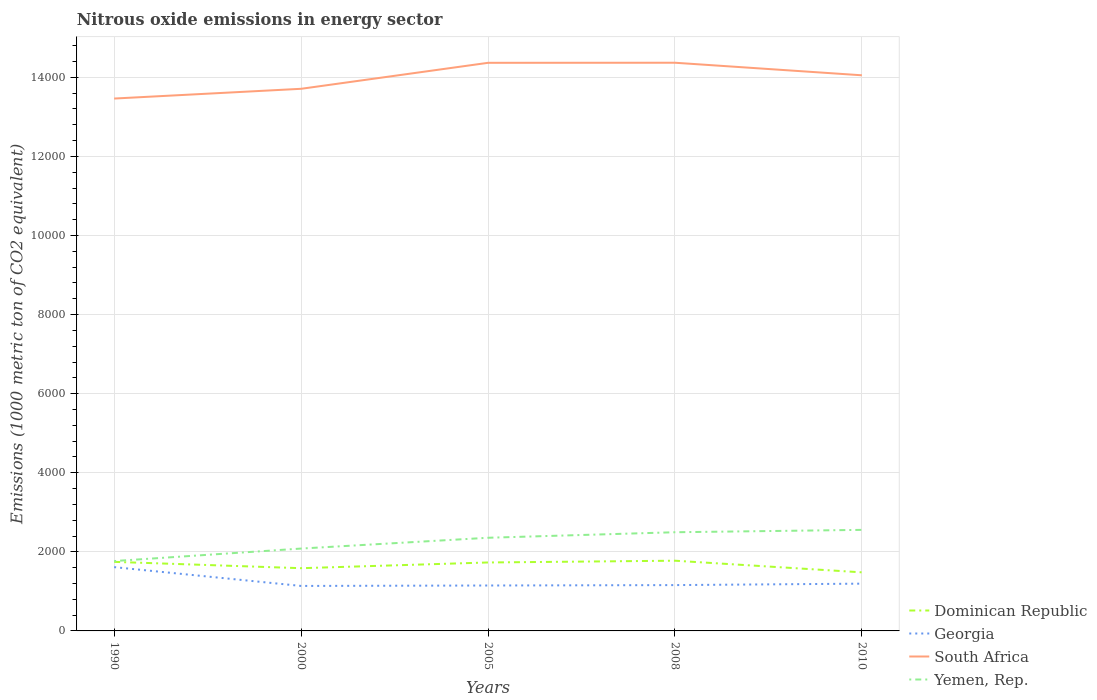Is the number of lines equal to the number of legend labels?
Make the answer very short. Yes. Across all years, what is the maximum amount of nitrous oxide emitted in Georgia?
Offer a very short reply. 1137.6. What is the total amount of nitrous oxide emitted in Dominican Republic in the graph?
Your answer should be compact. 294.2. What is the difference between the highest and the second highest amount of nitrous oxide emitted in South Africa?
Ensure brevity in your answer.  905.7. What is the difference between the highest and the lowest amount of nitrous oxide emitted in Dominican Republic?
Provide a short and direct response. 3. Is the amount of nitrous oxide emitted in South Africa strictly greater than the amount of nitrous oxide emitted in Yemen, Rep. over the years?
Provide a succinct answer. No. How many years are there in the graph?
Your answer should be very brief. 5. Does the graph contain grids?
Your response must be concise. Yes. How are the legend labels stacked?
Make the answer very short. Vertical. What is the title of the graph?
Provide a short and direct response. Nitrous oxide emissions in energy sector. Does "Portugal" appear as one of the legend labels in the graph?
Your response must be concise. No. What is the label or title of the Y-axis?
Provide a short and direct response. Emissions (1000 metric ton of CO2 equivalent). What is the Emissions (1000 metric ton of CO2 equivalent) of Dominican Republic in 1990?
Make the answer very short. 1746.5. What is the Emissions (1000 metric ton of CO2 equivalent) in Georgia in 1990?
Keep it short and to the point. 1613.4. What is the Emissions (1000 metric ton of CO2 equivalent) in South Africa in 1990?
Make the answer very short. 1.35e+04. What is the Emissions (1000 metric ton of CO2 equivalent) of Yemen, Rep. in 1990?
Make the answer very short. 1766.7. What is the Emissions (1000 metric ton of CO2 equivalent) of Dominican Republic in 2000?
Your answer should be very brief. 1586.4. What is the Emissions (1000 metric ton of CO2 equivalent) of Georgia in 2000?
Your response must be concise. 1137.6. What is the Emissions (1000 metric ton of CO2 equivalent) in South Africa in 2000?
Provide a succinct answer. 1.37e+04. What is the Emissions (1000 metric ton of CO2 equivalent) of Yemen, Rep. in 2000?
Provide a succinct answer. 2082.9. What is the Emissions (1000 metric ton of CO2 equivalent) in Dominican Republic in 2005?
Your response must be concise. 1731. What is the Emissions (1000 metric ton of CO2 equivalent) of Georgia in 2005?
Offer a terse response. 1148.6. What is the Emissions (1000 metric ton of CO2 equivalent) in South Africa in 2005?
Give a very brief answer. 1.44e+04. What is the Emissions (1000 metric ton of CO2 equivalent) in Yemen, Rep. in 2005?
Your answer should be very brief. 2356. What is the Emissions (1000 metric ton of CO2 equivalent) in Dominican Republic in 2008?
Your answer should be compact. 1775.7. What is the Emissions (1000 metric ton of CO2 equivalent) in Georgia in 2008?
Provide a short and direct response. 1158.8. What is the Emissions (1000 metric ton of CO2 equivalent) in South Africa in 2008?
Provide a short and direct response. 1.44e+04. What is the Emissions (1000 metric ton of CO2 equivalent) in Yemen, Rep. in 2008?
Your answer should be compact. 2495.7. What is the Emissions (1000 metric ton of CO2 equivalent) of Dominican Republic in 2010?
Your answer should be compact. 1481.5. What is the Emissions (1000 metric ton of CO2 equivalent) in Georgia in 2010?
Offer a terse response. 1195.6. What is the Emissions (1000 metric ton of CO2 equivalent) in South Africa in 2010?
Give a very brief answer. 1.41e+04. What is the Emissions (1000 metric ton of CO2 equivalent) of Yemen, Rep. in 2010?
Your answer should be very brief. 2555.7. Across all years, what is the maximum Emissions (1000 metric ton of CO2 equivalent) of Dominican Republic?
Your answer should be very brief. 1775.7. Across all years, what is the maximum Emissions (1000 metric ton of CO2 equivalent) of Georgia?
Provide a succinct answer. 1613.4. Across all years, what is the maximum Emissions (1000 metric ton of CO2 equivalent) of South Africa?
Provide a succinct answer. 1.44e+04. Across all years, what is the maximum Emissions (1000 metric ton of CO2 equivalent) in Yemen, Rep.?
Provide a succinct answer. 2555.7. Across all years, what is the minimum Emissions (1000 metric ton of CO2 equivalent) in Dominican Republic?
Give a very brief answer. 1481.5. Across all years, what is the minimum Emissions (1000 metric ton of CO2 equivalent) of Georgia?
Provide a succinct answer. 1137.6. Across all years, what is the minimum Emissions (1000 metric ton of CO2 equivalent) of South Africa?
Give a very brief answer. 1.35e+04. Across all years, what is the minimum Emissions (1000 metric ton of CO2 equivalent) in Yemen, Rep.?
Your answer should be compact. 1766.7. What is the total Emissions (1000 metric ton of CO2 equivalent) of Dominican Republic in the graph?
Give a very brief answer. 8321.1. What is the total Emissions (1000 metric ton of CO2 equivalent) in Georgia in the graph?
Your answer should be very brief. 6254. What is the total Emissions (1000 metric ton of CO2 equivalent) of South Africa in the graph?
Offer a terse response. 7.00e+04. What is the total Emissions (1000 metric ton of CO2 equivalent) of Yemen, Rep. in the graph?
Ensure brevity in your answer.  1.13e+04. What is the difference between the Emissions (1000 metric ton of CO2 equivalent) of Dominican Republic in 1990 and that in 2000?
Your answer should be compact. 160.1. What is the difference between the Emissions (1000 metric ton of CO2 equivalent) in Georgia in 1990 and that in 2000?
Provide a short and direct response. 475.8. What is the difference between the Emissions (1000 metric ton of CO2 equivalent) in South Africa in 1990 and that in 2000?
Offer a very short reply. -246.5. What is the difference between the Emissions (1000 metric ton of CO2 equivalent) of Yemen, Rep. in 1990 and that in 2000?
Provide a succinct answer. -316.2. What is the difference between the Emissions (1000 metric ton of CO2 equivalent) in Dominican Republic in 1990 and that in 2005?
Keep it short and to the point. 15.5. What is the difference between the Emissions (1000 metric ton of CO2 equivalent) of Georgia in 1990 and that in 2005?
Make the answer very short. 464.8. What is the difference between the Emissions (1000 metric ton of CO2 equivalent) of South Africa in 1990 and that in 2005?
Make the answer very short. -903.7. What is the difference between the Emissions (1000 metric ton of CO2 equivalent) in Yemen, Rep. in 1990 and that in 2005?
Your response must be concise. -589.3. What is the difference between the Emissions (1000 metric ton of CO2 equivalent) of Dominican Republic in 1990 and that in 2008?
Ensure brevity in your answer.  -29.2. What is the difference between the Emissions (1000 metric ton of CO2 equivalent) of Georgia in 1990 and that in 2008?
Offer a terse response. 454.6. What is the difference between the Emissions (1000 metric ton of CO2 equivalent) of South Africa in 1990 and that in 2008?
Ensure brevity in your answer.  -905.7. What is the difference between the Emissions (1000 metric ton of CO2 equivalent) of Yemen, Rep. in 1990 and that in 2008?
Your answer should be very brief. -729. What is the difference between the Emissions (1000 metric ton of CO2 equivalent) in Dominican Republic in 1990 and that in 2010?
Make the answer very short. 265. What is the difference between the Emissions (1000 metric ton of CO2 equivalent) of Georgia in 1990 and that in 2010?
Ensure brevity in your answer.  417.8. What is the difference between the Emissions (1000 metric ton of CO2 equivalent) in South Africa in 1990 and that in 2010?
Offer a very short reply. -588.2. What is the difference between the Emissions (1000 metric ton of CO2 equivalent) of Yemen, Rep. in 1990 and that in 2010?
Offer a very short reply. -789. What is the difference between the Emissions (1000 metric ton of CO2 equivalent) in Dominican Republic in 2000 and that in 2005?
Provide a short and direct response. -144.6. What is the difference between the Emissions (1000 metric ton of CO2 equivalent) of Georgia in 2000 and that in 2005?
Offer a terse response. -11. What is the difference between the Emissions (1000 metric ton of CO2 equivalent) of South Africa in 2000 and that in 2005?
Your response must be concise. -657.2. What is the difference between the Emissions (1000 metric ton of CO2 equivalent) in Yemen, Rep. in 2000 and that in 2005?
Provide a succinct answer. -273.1. What is the difference between the Emissions (1000 metric ton of CO2 equivalent) in Dominican Republic in 2000 and that in 2008?
Offer a terse response. -189.3. What is the difference between the Emissions (1000 metric ton of CO2 equivalent) in Georgia in 2000 and that in 2008?
Offer a very short reply. -21.2. What is the difference between the Emissions (1000 metric ton of CO2 equivalent) of South Africa in 2000 and that in 2008?
Ensure brevity in your answer.  -659.2. What is the difference between the Emissions (1000 metric ton of CO2 equivalent) in Yemen, Rep. in 2000 and that in 2008?
Ensure brevity in your answer.  -412.8. What is the difference between the Emissions (1000 metric ton of CO2 equivalent) in Dominican Republic in 2000 and that in 2010?
Provide a short and direct response. 104.9. What is the difference between the Emissions (1000 metric ton of CO2 equivalent) in Georgia in 2000 and that in 2010?
Your response must be concise. -58. What is the difference between the Emissions (1000 metric ton of CO2 equivalent) of South Africa in 2000 and that in 2010?
Your response must be concise. -341.7. What is the difference between the Emissions (1000 metric ton of CO2 equivalent) in Yemen, Rep. in 2000 and that in 2010?
Make the answer very short. -472.8. What is the difference between the Emissions (1000 metric ton of CO2 equivalent) in Dominican Republic in 2005 and that in 2008?
Make the answer very short. -44.7. What is the difference between the Emissions (1000 metric ton of CO2 equivalent) in South Africa in 2005 and that in 2008?
Provide a short and direct response. -2. What is the difference between the Emissions (1000 metric ton of CO2 equivalent) in Yemen, Rep. in 2005 and that in 2008?
Your answer should be compact. -139.7. What is the difference between the Emissions (1000 metric ton of CO2 equivalent) of Dominican Republic in 2005 and that in 2010?
Make the answer very short. 249.5. What is the difference between the Emissions (1000 metric ton of CO2 equivalent) of Georgia in 2005 and that in 2010?
Provide a succinct answer. -47. What is the difference between the Emissions (1000 metric ton of CO2 equivalent) in South Africa in 2005 and that in 2010?
Your answer should be very brief. 315.5. What is the difference between the Emissions (1000 metric ton of CO2 equivalent) of Yemen, Rep. in 2005 and that in 2010?
Give a very brief answer. -199.7. What is the difference between the Emissions (1000 metric ton of CO2 equivalent) of Dominican Republic in 2008 and that in 2010?
Make the answer very short. 294.2. What is the difference between the Emissions (1000 metric ton of CO2 equivalent) in Georgia in 2008 and that in 2010?
Provide a succinct answer. -36.8. What is the difference between the Emissions (1000 metric ton of CO2 equivalent) of South Africa in 2008 and that in 2010?
Give a very brief answer. 317.5. What is the difference between the Emissions (1000 metric ton of CO2 equivalent) of Yemen, Rep. in 2008 and that in 2010?
Ensure brevity in your answer.  -60. What is the difference between the Emissions (1000 metric ton of CO2 equivalent) of Dominican Republic in 1990 and the Emissions (1000 metric ton of CO2 equivalent) of Georgia in 2000?
Give a very brief answer. 608.9. What is the difference between the Emissions (1000 metric ton of CO2 equivalent) of Dominican Republic in 1990 and the Emissions (1000 metric ton of CO2 equivalent) of South Africa in 2000?
Offer a terse response. -1.20e+04. What is the difference between the Emissions (1000 metric ton of CO2 equivalent) in Dominican Republic in 1990 and the Emissions (1000 metric ton of CO2 equivalent) in Yemen, Rep. in 2000?
Give a very brief answer. -336.4. What is the difference between the Emissions (1000 metric ton of CO2 equivalent) of Georgia in 1990 and the Emissions (1000 metric ton of CO2 equivalent) of South Africa in 2000?
Keep it short and to the point. -1.21e+04. What is the difference between the Emissions (1000 metric ton of CO2 equivalent) in Georgia in 1990 and the Emissions (1000 metric ton of CO2 equivalent) in Yemen, Rep. in 2000?
Make the answer very short. -469.5. What is the difference between the Emissions (1000 metric ton of CO2 equivalent) in South Africa in 1990 and the Emissions (1000 metric ton of CO2 equivalent) in Yemen, Rep. in 2000?
Offer a terse response. 1.14e+04. What is the difference between the Emissions (1000 metric ton of CO2 equivalent) of Dominican Republic in 1990 and the Emissions (1000 metric ton of CO2 equivalent) of Georgia in 2005?
Give a very brief answer. 597.9. What is the difference between the Emissions (1000 metric ton of CO2 equivalent) of Dominican Republic in 1990 and the Emissions (1000 metric ton of CO2 equivalent) of South Africa in 2005?
Provide a succinct answer. -1.26e+04. What is the difference between the Emissions (1000 metric ton of CO2 equivalent) in Dominican Republic in 1990 and the Emissions (1000 metric ton of CO2 equivalent) in Yemen, Rep. in 2005?
Provide a succinct answer. -609.5. What is the difference between the Emissions (1000 metric ton of CO2 equivalent) in Georgia in 1990 and the Emissions (1000 metric ton of CO2 equivalent) in South Africa in 2005?
Give a very brief answer. -1.28e+04. What is the difference between the Emissions (1000 metric ton of CO2 equivalent) in Georgia in 1990 and the Emissions (1000 metric ton of CO2 equivalent) in Yemen, Rep. in 2005?
Offer a very short reply. -742.6. What is the difference between the Emissions (1000 metric ton of CO2 equivalent) in South Africa in 1990 and the Emissions (1000 metric ton of CO2 equivalent) in Yemen, Rep. in 2005?
Your response must be concise. 1.11e+04. What is the difference between the Emissions (1000 metric ton of CO2 equivalent) in Dominican Republic in 1990 and the Emissions (1000 metric ton of CO2 equivalent) in Georgia in 2008?
Your answer should be very brief. 587.7. What is the difference between the Emissions (1000 metric ton of CO2 equivalent) of Dominican Republic in 1990 and the Emissions (1000 metric ton of CO2 equivalent) of South Africa in 2008?
Provide a succinct answer. -1.26e+04. What is the difference between the Emissions (1000 metric ton of CO2 equivalent) in Dominican Republic in 1990 and the Emissions (1000 metric ton of CO2 equivalent) in Yemen, Rep. in 2008?
Your answer should be very brief. -749.2. What is the difference between the Emissions (1000 metric ton of CO2 equivalent) in Georgia in 1990 and the Emissions (1000 metric ton of CO2 equivalent) in South Africa in 2008?
Your answer should be compact. -1.28e+04. What is the difference between the Emissions (1000 metric ton of CO2 equivalent) of Georgia in 1990 and the Emissions (1000 metric ton of CO2 equivalent) of Yemen, Rep. in 2008?
Make the answer very short. -882.3. What is the difference between the Emissions (1000 metric ton of CO2 equivalent) of South Africa in 1990 and the Emissions (1000 metric ton of CO2 equivalent) of Yemen, Rep. in 2008?
Your answer should be compact. 1.10e+04. What is the difference between the Emissions (1000 metric ton of CO2 equivalent) in Dominican Republic in 1990 and the Emissions (1000 metric ton of CO2 equivalent) in Georgia in 2010?
Provide a short and direct response. 550.9. What is the difference between the Emissions (1000 metric ton of CO2 equivalent) in Dominican Republic in 1990 and the Emissions (1000 metric ton of CO2 equivalent) in South Africa in 2010?
Give a very brief answer. -1.23e+04. What is the difference between the Emissions (1000 metric ton of CO2 equivalent) in Dominican Republic in 1990 and the Emissions (1000 metric ton of CO2 equivalent) in Yemen, Rep. in 2010?
Your response must be concise. -809.2. What is the difference between the Emissions (1000 metric ton of CO2 equivalent) of Georgia in 1990 and the Emissions (1000 metric ton of CO2 equivalent) of South Africa in 2010?
Your response must be concise. -1.24e+04. What is the difference between the Emissions (1000 metric ton of CO2 equivalent) of Georgia in 1990 and the Emissions (1000 metric ton of CO2 equivalent) of Yemen, Rep. in 2010?
Your answer should be very brief. -942.3. What is the difference between the Emissions (1000 metric ton of CO2 equivalent) of South Africa in 1990 and the Emissions (1000 metric ton of CO2 equivalent) of Yemen, Rep. in 2010?
Provide a succinct answer. 1.09e+04. What is the difference between the Emissions (1000 metric ton of CO2 equivalent) in Dominican Republic in 2000 and the Emissions (1000 metric ton of CO2 equivalent) in Georgia in 2005?
Your answer should be very brief. 437.8. What is the difference between the Emissions (1000 metric ton of CO2 equivalent) in Dominican Republic in 2000 and the Emissions (1000 metric ton of CO2 equivalent) in South Africa in 2005?
Provide a short and direct response. -1.28e+04. What is the difference between the Emissions (1000 metric ton of CO2 equivalent) in Dominican Republic in 2000 and the Emissions (1000 metric ton of CO2 equivalent) in Yemen, Rep. in 2005?
Your answer should be compact. -769.6. What is the difference between the Emissions (1000 metric ton of CO2 equivalent) of Georgia in 2000 and the Emissions (1000 metric ton of CO2 equivalent) of South Africa in 2005?
Provide a short and direct response. -1.32e+04. What is the difference between the Emissions (1000 metric ton of CO2 equivalent) in Georgia in 2000 and the Emissions (1000 metric ton of CO2 equivalent) in Yemen, Rep. in 2005?
Give a very brief answer. -1218.4. What is the difference between the Emissions (1000 metric ton of CO2 equivalent) in South Africa in 2000 and the Emissions (1000 metric ton of CO2 equivalent) in Yemen, Rep. in 2005?
Your answer should be compact. 1.14e+04. What is the difference between the Emissions (1000 metric ton of CO2 equivalent) in Dominican Republic in 2000 and the Emissions (1000 metric ton of CO2 equivalent) in Georgia in 2008?
Your response must be concise. 427.6. What is the difference between the Emissions (1000 metric ton of CO2 equivalent) in Dominican Republic in 2000 and the Emissions (1000 metric ton of CO2 equivalent) in South Africa in 2008?
Provide a short and direct response. -1.28e+04. What is the difference between the Emissions (1000 metric ton of CO2 equivalent) of Dominican Republic in 2000 and the Emissions (1000 metric ton of CO2 equivalent) of Yemen, Rep. in 2008?
Your answer should be very brief. -909.3. What is the difference between the Emissions (1000 metric ton of CO2 equivalent) of Georgia in 2000 and the Emissions (1000 metric ton of CO2 equivalent) of South Africa in 2008?
Offer a very short reply. -1.32e+04. What is the difference between the Emissions (1000 metric ton of CO2 equivalent) of Georgia in 2000 and the Emissions (1000 metric ton of CO2 equivalent) of Yemen, Rep. in 2008?
Give a very brief answer. -1358.1. What is the difference between the Emissions (1000 metric ton of CO2 equivalent) in South Africa in 2000 and the Emissions (1000 metric ton of CO2 equivalent) in Yemen, Rep. in 2008?
Ensure brevity in your answer.  1.12e+04. What is the difference between the Emissions (1000 metric ton of CO2 equivalent) of Dominican Republic in 2000 and the Emissions (1000 metric ton of CO2 equivalent) of Georgia in 2010?
Offer a terse response. 390.8. What is the difference between the Emissions (1000 metric ton of CO2 equivalent) in Dominican Republic in 2000 and the Emissions (1000 metric ton of CO2 equivalent) in South Africa in 2010?
Your answer should be compact. -1.25e+04. What is the difference between the Emissions (1000 metric ton of CO2 equivalent) in Dominican Republic in 2000 and the Emissions (1000 metric ton of CO2 equivalent) in Yemen, Rep. in 2010?
Your response must be concise. -969.3. What is the difference between the Emissions (1000 metric ton of CO2 equivalent) of Georgia in 2000 and the Emissions (1000 metric ton of CO2 equivalent) of South Africa in 2010?
Offer a very short reply. -1.29e+04. What is the difference between the Emissions (1000 metric ton of CO2 equivalent) in Georgia in 2000 and the Emissions (1000 metric ton of CO2 equivalent) in Yemen, Rep. in 2010?
Give a very brief answer. -1418.1. What is the difference between the Emissions (1000 metric ton of CO2 equivalent) in South Africa in 2000 and the Emissions (1000 metric ton of CO2 equivalent) in Yemen, Rep. in 2010?
Your answer should be compact. 1.12e+04. What is the difference between the Emissions (1000 metric ton of CO2 equivalent) in Dominican Republic in 2005 and the Emissions (1000 metric ton of CO2 equivalent) in Georgia in 2008?
Your response must be concise. 572.2. What is the difference between the Emissions (1000 metric ton of CO2 equivalent) in Dominican Republic in 2005 and the Emissions (1000 metric ton of CO2 equivalent) in South Africa in 2008?
Your response must be concise. -1.26e+04. What is the difference between the Emissions (1000 metric ton of CO2 equivalent) in Dominican Republic in 2005 and the Emissions (1000 metric ton of CO2 equivalent) in Yemen, Rep. in 2008?
Give a very brief answer. -764.7. What is the difference between the Emissions (1000 metric ton of CO2 equivalent) in Georgia in 2005 and the Emissions (1000 metric ton of CO2 equivalent) in South Africa in 2008?
Your answer should be compact. -1.32e+04. What is the difference between the Emissions (1000 metric ton of CO2 equivalent) of Georgia in 2005 and the Emissions (1000 metric ton of CO2 equivalent) of Yemen, Rep. in 2008?
Offer a very short reply. -1347.1. What is the difference between the Emissions (1000 metric ton of CO2 equivalent) of South Africa in 2005 and the Emissions (1000 metric ton of CO2 equivalent) of Yemen, Rep. in 2008?
Keep it short and to the point. 1.19e+04. What is the difference between the Emissions (1000 metric ton of CO2 equivalent) of Dominican Republic in 2005 and the Emissions (1000 metric ton of CO2 equivalent) of Georgia in 2010?
Provide a short and direct response. 535.4. What is the difference between the Emissions (1000 metric ton of CO2 equivalent) in Dominican Republic in 2005 and the Emissions (1000 metric ton of CO2 equivalent) in South Africa in 2010?
Your answer should be compact. -1.23e+04. What is the difference between the Emissions (1000 metric ton of CO2 equivalent) of Dominican Republic in 2005 and the Emissions (1000 metric ton of CO2 equivalent) of Yemen, Rep. in 2010?
Keep it short and to the point. -824.7. What is the difference between the Emissions (1000 metric ton of CO2 equivalent) of Georgia in 2005 and the Emissions (1000 metric ton of CO2 equivalent) of South Africa in 2010?
Make the answer very short. -1.29e+04. What is the difference between the Emissions (1000 metric ton of CO2 equivalent) of Georgia in 2005 and the Emissions (1000 metric ton of CO2 equivalent) of Yemen, Rep. in 2010?
Keep it short and to the point. -1407.1. What is the difference between the Emissions (1000 metric ton of CO2 equivalent) in South Africa in 2005 and the Emissions (1000 metric ton of CO2 equivalent) in Yemen, Rep. in 2010?
Keep it short and to the point. 1.18e+04. What is the difference between the Emissions (1000 metric ton of CO2 equivalent) in Dominican Republic in 2008 and the Emissions (1000 metric ton of CO2 equivalent) in Georgia in 2010?
Your response must be concise. 580.1. What is the difference between the Emissions (1000 metric ton of CO2 equivalent) in Dominican Republic in 2008 and the Emissions (1000 metric ton of CO2 equivalent) in South Africa in 2010?
Your answer should be very brief. -1.23e+04. What is the difference between the Emissions (1000 metric ton of CO2 equivalent) of Dominican Republic in 2008 and the Emissions (1000 metric ton of CO2 equivalent) of Yemen, Rep. in 2010?
Ensure brevity in your answer.  -780. What is the difference between the Emissions (1000 metric ton of CO2 equivalent) of Georgia in 2008 and the Emissions (1000 metric ton of CO2 equivalent) of South Africa in 2010?
Your answer should be very brief. -1.29e+04. What is the difference between the Emissions (1000 metric ton of CO2 equivalent) of Georgia in 2008 and the Emissions (1000 metric ton of CO2 equivalent) of Yemen, Rep. in 2010?
Your answer should be very brief. -1396.9. What is the difference between the Emissions (1000 metric ton of CO2 equivalent) in South Africa in 2008 and the Emissions (1000 metric ton of CO2 equivalent) in Yemen, Rep. in 2010?
Make the answer very short. 1.18e+04. What is the average Emissions (1000 metric ton of CO2 equivalent) of Dominican Republic per year?
Keep it short and to the point. 1664.22. What is the average Emissions (1000 metric ton of CO2 equivalent) of Georgia per year?
Offer a very short reply. 1250.8. What is the average Emissions (1000 metric ton of CO2 equivalent) in South Africa per year?
Offer a very short reply. 1.40e+04. What is the average Emissions (1000 metric ton of CO2 equivalent) of Yemen, Rep. per year?
Your response must be concise. 2251.4. In the year 1990, what is the difference between the Emissions (1000 metric ton of CO2 equivalent) in Dominican Republic and Emissions (1000 metric ton of CO2 equivalent) in Georgia?
Give a very brief answer. 133.1. In the year 1990, what is the difference between the Emissions (1000 metric ton of CO2 equivalent) of Dominican Republic and Emissions (1000 metric ton of CO2 equivalent) of South Africa?
Keep it short and to the point. -1.17e+04. In the year 1990, what is the difference between the Emissions (1000 metric ton of CO2 equivalent) in Dominican Republic and Emissions (1000 metric ton of CO2 equivalent) in Yemen, Rep.?
Offer a terse response. -20.2. In the year 1990, what is the difference between the Emissions (1000 metric ton of CO2 equivalent) in Georgia and Emissions (1000 metric ton of CO2 equivalent) in South Africa?
Make the answer very short. -1.18e+04. In the year 1990, what is the difference between the Emissions (1000 metric ton of CO2 equivalent) in Georgia and Emissions (1000 metric ton of CO2 equivalent) in Yemen, Rep.?
Make the answer very short. -153.3. In the year 1990, what is the difference between the Emissions (1000 metric ton of CO2 equivalent) in South Africa and Emissions (1000 metric ton of CO2 equivalent) in Yemen, Rep.?
Give a very brief answer. 1.17e+04. In the year 2000, what is the difference between the Emissions (1000 metric ton of CO2 equivalent) of Dominican Republic and Emissions (1000 metric ton of CO2 equivalent) of Georgia?
Offer a terse response. 448.8. In the year 2000, what is the difference between the Emissions (1000 metric ton of CO2 equivalent) in Dominican Republic and Emissions (1000 metric ton of CO2 equivalent) in South Africa?
Give a very brief answer. -1.21e+04. In the year 2000, what is the difference between the Emissions (1000 metric ton of CO2 equivalent) in Dominican Republic and Emissions (1000 metric ton of CO2 equivalent) in Yemen, Rep.?
Give a very brief answer. -496.5. In the year 2000, what is the difference between the Emissions (1000 metric ton of CO2 equivalent) of Georgia and Emissions (1000 metric ton of CO2 equivalent) of South Africa?
Give a very brief answer. -1.26e+04. In the year 2000, what is the difference between the Emissions (1000 metric ton of CO2 equivalent) in Georgia and Emissions (1000 metric ton of CO2 equivalent) in Yemen, Rep.?
Give a very brief answer. -945.3. In the year 2000, what is the difference between the Emissions (1000 metric ton of CO2 equivalent) of South Africa and Emissions (1000 metric ton of CO2 equivalent) of Yemen, Rep.?
Give a very brief answer. 1.16e+04. In the year 2005, what is the difference between the Emissions (1000 metric ton of CO2 equivalent) of Dominican Republic and Emissions (1000 metric ton of CO2 equivalent) of Georgia?
Make the answer very short. 582.4. In the year 2005, what is the difference between the Emissions (1000 metric ton of CO2 equivalent) in Dominican Republic and Emissions (1000 metric ton of CO2 equivalent) in South Africa?
Your answer should be compact. -1.26e+04. In the year 2005, what is the difference between the Emissions (1000 metric ton of CO2 equivalent) in Dominican Republic and Emissions (1000 metric ton of CO2 equivalent) in Yemen, Rep.?
Your answer should be very brief. -625. In the year 2005, what is the difference between the Emissions (1000 metric ton of CO2 equivalent) in Georgia and Emissions (1000 metric ton of CO2 equivalent) in South Africa?
Make the answer very short. -1.32e+04. In the year 2005, what is the difference between the Emissions (1000 metric ton of CO2 equivalent) of Georgia and Emissions (1000 metric ton of CO2 equivalent) of Yemen, Rep.?
Ensure brevity in your answer.  -1207.4. In the year 2005, what is the difference between the Emissions (1000 metric ton of CO2 equivalent) in South Africa and Emissions (1000 metric ton of CO2 equivalent) in Yemen, Rep.?
Offer a terse response. 1.20e+04. In the year 2008, what is the difference between the Emissions (1000 metric ton of CO2 equivalent) of Dominican Republic and Emissions (1000 metric ton of CO2 equivalent) of Georgia?
Give a very brief answer. 616.9. In the year 2008, what is the difference between the Emissions (1000 metric ton of CO2 equivalent) in Dominican Republic and Emissions (1000 metric ton of CO2 equivalent) in South Africa?
Keep it short and to the point. -1.26e+04. In the year 2008, what is the difference between the Emissions (1000 metric ton of CO2 equivalent) in Dominican Republic and Emissions (1000 metric ton of CO2 equivalent) in Yemen, Rep.?
Ensure brevity in your answer.  -720. In the year 2008, what is the difference between the Emissions (1000 metric ton of CO2 equivalent) in Georgia and Emissions (1000 metric ton of CO2 equivalent) in South Africa?
Your answer should be compact. -1.32e+04. In the year 2008, what is the difference between the Emissions (1000 metric ton of CO2 equivalent) in Georgia and Emissions (1000 metric ton of CO2 equivalent) in Yemen, Rep.?
Give a very brief answer. -1336.9. In the year 2008, what is the difference between the Emissions (1000 metric ton of CO2 equivalent) in South Africa and Emissions (1000 metric ton of CO2 equivalent) in Yemen, Rep.?
Keep it short and to the point. 1.19e+04. In the year 2010, what is the difference between the Emissions (1000 metric ton of CO2 equivalent) of Dominican Republic and Emissions (1000 metric ton of CO2 equivalent) of Georgia?
Your answer should be compact. 285.9. In the year 2010, what is the difference between the Emissions (1000 metric ton of CO2 equivalent) in Dominican Republic and Emissions (1000 metric ton of CO2 equivalent) in South Africa?
Give a very brief answer. -1.26e+04. In the year 2010, what is the difference between the Emissions (1000 metric ton of CO2 equivalent) in Dominican Republic and Emissions (1000 metric ton of CO2 equivalent) in Yemen, Rep.?
Provide a short and direct response. -1074.2. In the year 2010, what is the difference between the Emissions (1000 metric ton of CO2 equivalent) in Georgia and Emissions (1000 metric ton of CO2 equivalent) in South Africa?
Give a very brief answer. -1.29e+04. In the year 2010, what is the difference between the Emissions (1000 metric ton of CO2 equivalent) in Georgia and Emissions (1000 metric ton of CO2 equivalent) in Yemen, Rep.?
Ensure brevity in your answer.  -1360.1. In the year 2010, what is the difference between the Emissions (1000 metric ton of CO2 equivalent) of South Africa and Emissions (1000 metric ton of CO2 equivalent) of Yemen, Rep.?
Make the answer very short. 1.15e+04. What is the ratio of the Emissions (1000 metric ton of CO2 equivalent) in Dominican Republic in 1990 to that in 2000?
Your answer should be very brief. 1.1. What is the ratio of the Emissions (1000 metric ton of CO2 equivalent) in Georgia in 1990 to that in 2000?
Make the answer very short. 1.42. What is the ratio of the Emissions (1000 metric ton of CO2 equivalent) in Yemen, Rep. in 1990 to that in 2000?
Keep it short and to the point. 0.85. What is the ratio of the Emissions (1000 metric ton of CO2 equivalent) of Georgia in 1990 to that in 2005?
Ensure brevity in your answer.  1.4. What is the ratio of the Emissions (1000 metric ton of CO2 equivalent) of South Africa in 1990 to that in 2005?
Ensure brevity in your answer.  0.94. What is the ratio of the Emissions (1000 metric ton of CO2 equivalent) of Yemen, Rep. in 1990 to that in 2005?
Your answer should be very brief. 0.75. What is the ratio of the Emissions (1000 metric ton of CO2 equivalent) of Dominican Republic in 1990 to that in 2008?
Offer a very short reply. 0.98. What is the ratio of the Emissions (1000 metric ton of CO2 equivalent) of Georgia in 1990 to that in 2008?
Your answer should be compact. 1.39. What is the ratio of the Emissions (1000 metric ton of CO2 equivalent) in South Africa in 1990 to that in 2008?
Offer a terse response. 0.94. What is the ratio of the Emissions (1000 metric ton of CO2 equivalent) of Yemen, Rep. in 1990 to that in 2008?
Your response must be concise. 0.71. What is the ratio of the Emissions (1000 metric ton of CO2 equivalent) in Dominican Republic in 1990 to that in 2010?
Ensure brevity in your answer.  1.18. What is the ratio of the Emissions (1000 metric ton of CO2 equivalent) of Georgia in 1990 to that in 2010?
Your response must be concise. 1.35. What is the ratio of the Emissions (1000 metric ton of CO2 equivalent) of South Africa in 1990 to that in 2010?
Provide a short and direct response. 0.96. What is the ratio of the Emissions (1000 metric ton of CO2 equivalent) of Yemen, Rep. in 1990 to that in 2010?
Provide a short and direct response. 0.69. What is the ratio of the Emissions (1000 metric ton of CO2 equivalent) in Dominican Republic in 2000 to that in 2005?
Your answer should be very brief. 0.92. What is the ratio of the Emissions (1000 metric ton of CO2 equivalent) in Georgia in 2000 to that in 2005?
Your answer should be very brief. 0.99. What is the ratio of the Emissions (1000 metric ton of CO2 equivalent) in South Africa in 2000 to that in 2005?
Provide a short and direct response. 0.95. What is the ratio of the Emissions (1000 metric ton of CO2 equivalent) in Yemen, Rep. in 2000 to that in 2005?
Make the answer very short. 0.88. What is the ratio of the Emissions (1000 metric ton of CO2 equivalent) in Dominican Republic in 2000 to that in 2008?
Provide a short and direct response. 0.89. What is the ratio of the Emissions (1000 metric ton of CO2 equivalent) of Georgia in 2000 to that in 2008?
Give a very brief answer. 0.98. What is the ratio of the Emissions (1000 metric ton of CO2 equivalent) in South Africa in 2000 to that in 2008?
Your response must be concise. 0.95. What is the ratio of the Emissions (1000 metric ton of CO2 equivalent) in Yemen, Rep. in 2000 to that in 2008?
Your response must be concise. 0.83. What is the ratio of the Emissions (1000 metric ton of CO2 equivalent) of Dominican Republic in 2000 to that in 2010?
Your answer should be compact. 1.07. What is the ratio of the Emissions (1000 metric ton of CO2 equivalent) of Georgia in 2000 to that in 2010?
Offer a terse response. 0.95. What is the ratio of the Emissions (1000 metric ton of CO2 equivalent) in South Africa in 2000 to that in 2010?
Your answer should be very brief. 0.98. What is the ratio of the Emissions (1000 metric ton of CO2 equivalent) in Yemen, Rep. in 2000 to that in 2010?
Your response must be concise. 0.81. What is the ratio of the Emissions (1000 metric ton of CO2 equivalent) in Dominican Republic in 2005 to that in 2008?
Make the answer very short. 0.97. What is the ratio of the Emissions (1000 metric ton of CO2 equivalent) in South Africa in 2005 to that in 2008?
Make the answer very short. 1. What is the ratio of the Emissions (1000 metric ton of CO2 equivalent) in Yemen, Rep. in 2005 to that in 2008?
Your answer should be very brief. 0.94. What is the ratio of the Emissions (1000 metric ton of CO2 equivalent) of Dominican Republic in 2005 to that in 2010?
Offer a very short reply. 1.17. What is the ratio of the Emissions (1000 metric ton of CO2 equivalent) in Georgia in 2005 to that in 2010?
Keep it short and to the point. 0.96. What is the ratio of the Emissions (1000 metric ton of CO2 equivalent) of South Africa in 2005 to that in 2010?
Offer a terse response. 1.02. What is the ratio of the Emissions (1000 metric ton of CO2 equivalent) of Yemen, Rep. in 2005 to that in 2010?
Your response must be concise. 0.92. What is the ratio of the Emissions (1000 metric ton of CO2 equivalent) in Dominican Republic in 2008 to that in 2010?
Give a very brief answer. 1.2. What is the ratio of the Emissions (1000 metric ton of CO2 equivalent) in Georgia in 2008 to that in 2010?
Provide a succinct answer. 0.97. What is the ratio of the Emissions (1000 metric ton of CO2 equivalent) in South Africa in 2008 to that in 2010?
Make the answer very short. 1.02. What is the ratio of the Emissions (1000 metric ton of CO2 equivalent) of Yemen, Rep. in 2008 to that in 2010?
Provide a succinct answer. 0.98. What is the difference between the highest and the second highest Emissions (1000 metric ton of CO2 equivalent) of Dominican Republic?
Ensure brevity in your answer.  29.2. What is the difference between the highest and the second highest Emissions (1000 metric ton of CO2 equivalent) of Georgia?
Offer a terse response. 417.8. What is the difference between the highest and the lowest Emissions (1000 metric ton of CO2 equivalent) of Dominican Republic?
Provide a short and direct response. 294.2. What is the difference between the highest and the lowest Emissions (1000 metric ton of CO2 equivalent) of Georgia?
Offer a terse response. 475.8. What is the difference between the highest and the lowest Emissions (1000 metric ton of CO2 equivalent) of South Africa?
Your answer should be compact. 905.7. What is the difference between the highest and the lowest Emissions (1000 metric ton of CO2 equivalent) in Yemen, Rep.?
Your response must be concise. 789. 